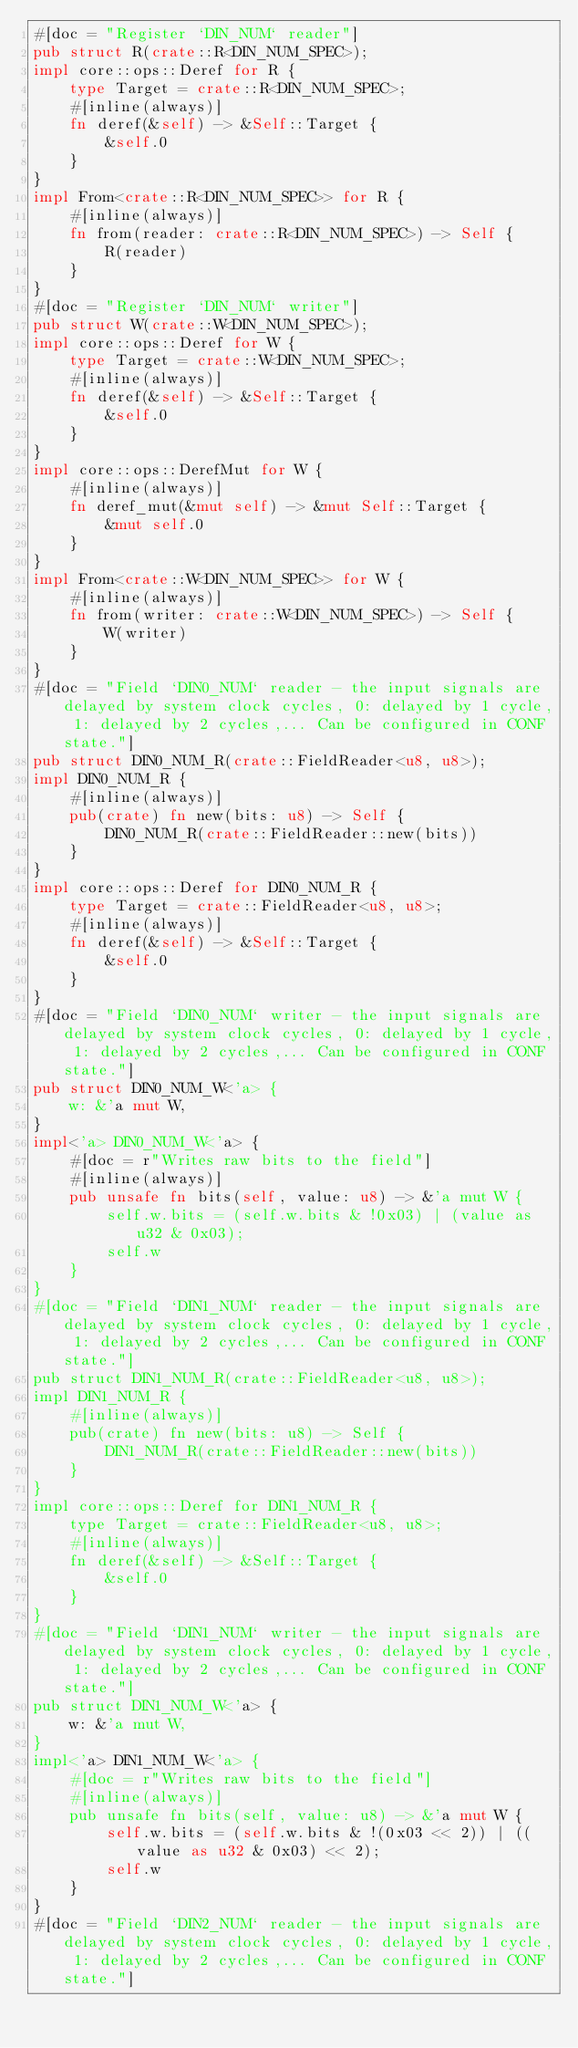Convert code to text. <code><loc_0><loc_0><loc_500><loc_500><_Rust_>#[doc = "Register `DIN_NUM` reader"]
pub struct R(crate::R<DIN_NUM_SPEC>);
impl core::ops::Deref for R {
    type Target = crate::R<DIN_NUM_SPEC>;
    #[inline(always)]
    fn deref(&self) -> &Self::Target {
        &self.0
    }
}
impl From<crate::R<DIN_NUM_SPEC>> for R {
    #[inline(always)]
    fn from(reader: crate::R<DIN_NUM_SPEC>) -> Self {
        R(reader)
    }
}
#[doc = "Register `DIN_NUM` writer"]
pub struct W(crate::W<DIN_NUM_SPEC>);
impl core::ops::Deref for W {
    type Target = crate::W<DIN_NUM_SPEC>;
    #[inline(always)]
    fn deref(&self) -> &Self::Target {
        &self.0
    }
}
impl core::ops::DerefMut for W {
    #[inline(always)]
    fn deref_mut(&mut self) -> &mut Self::Target {
        &mut self.0
    }
}
impl From<crate::W<DIN_NUM_SPEC>> for W {
    #[inline(always)]
    fn from(writer: crate::W<DIN_NUM_SPEC>) -> Self {
        W(writer)
    }
}
#[doc = "Field `DIN0_NUM` reader - the input signals are delayed by system clock cycles, 0: delayed by 1 cycle, 1: delayed by 2 cycles,... Can be configured in CONF state."]
pub struct DIN0_NUM_R(crate::FieldReader<u8, u8>);
impl DIN0_NUM_R {
    #[inline(always)]
    pub(crate) fn new(bits: u8) -> Self {
        DIN0_NUM_R(crate::FieldReader::new(bits))
    }
}
impl core::ops::Deref for DIN0_NUM_R {
    type Target = crate::FieldReader<u8, u8>;
    #[inline(always)]
    fn deref(&self) -> &Self::Target {
        &self.0
    }
}
#[doc = "Field `DIN0_NUM` writer - the input signals are delayed by system clock cycles, 0: delayed by 1 cycle, 1: delayed by 2 cycles,... Can be configured in CONF state."]
pub struct DIN0_NUM_W<'a> {
    w: &'a mut W,
}
impl<'a> DIN0_NUM_W<'a> {
    #[doc = r"Writes raw bits to the field"]
    #[inline(always)]
    pub unsafe fn bits(self, value: u8) -> &'a mut W {
        self.w.bits = (self.w.bits & !0x03) | (value as u32 & 0x03);
        self.w
    }
}
#[doc = "Field `DIN1_NUM` reader - the input signals are delayed by system clock cycles, 0: delayed by 1 cycle, 1: delayed by 2 cycles,... Can be configured in CONF state."]
pub struct DIN1_NUM_R(crate::FieldReader<u8, u8>);
impl DIN1_NUM_R {
    #[inline(always)]
    pub(crate) fn new(bits: u8) -> Self {
        DIN1_NUM_R(crate::FieldReader::new(bits))
    }
}
impl core::ops::Deref for DIN1_NUM_R {
    type Target = crate::FieldReader<u8, u8>;
    #[inline(always)]
    fn deref(&self) -> &Self::Target {
        &self.0
    }
}
#[doc = "Field `DIN1_NUM` writer - the input signals are delayed by system clock cycles, 0: delayed by 1 cycle, 1: delayed by 2 cycles,... Can be configured in CONF state."]
pub struct DIN1_NUM_W<'a> {
    w: &'a mut W,
}
impl<'a> DIN1_NUM_W<'a> {
    #[doc = r"Writes raw bits to the field"]
    #[inline(always)]
    pub unsafe fn bits(self, value: u8) -> &'a mut W {
        self.w.bits = (self.w.bits & !(0x03 << 2)) | ((value as u32 & 0x03) << 2);
        self.w
    }
}
#[doc = "Field `DIN2_NUM` reader - the input signals are delayed by system clock cycles, 0: delayed by 1 cycle, 1: delayed by 2 cycles,... Can be configured in CONF state."]</code> 